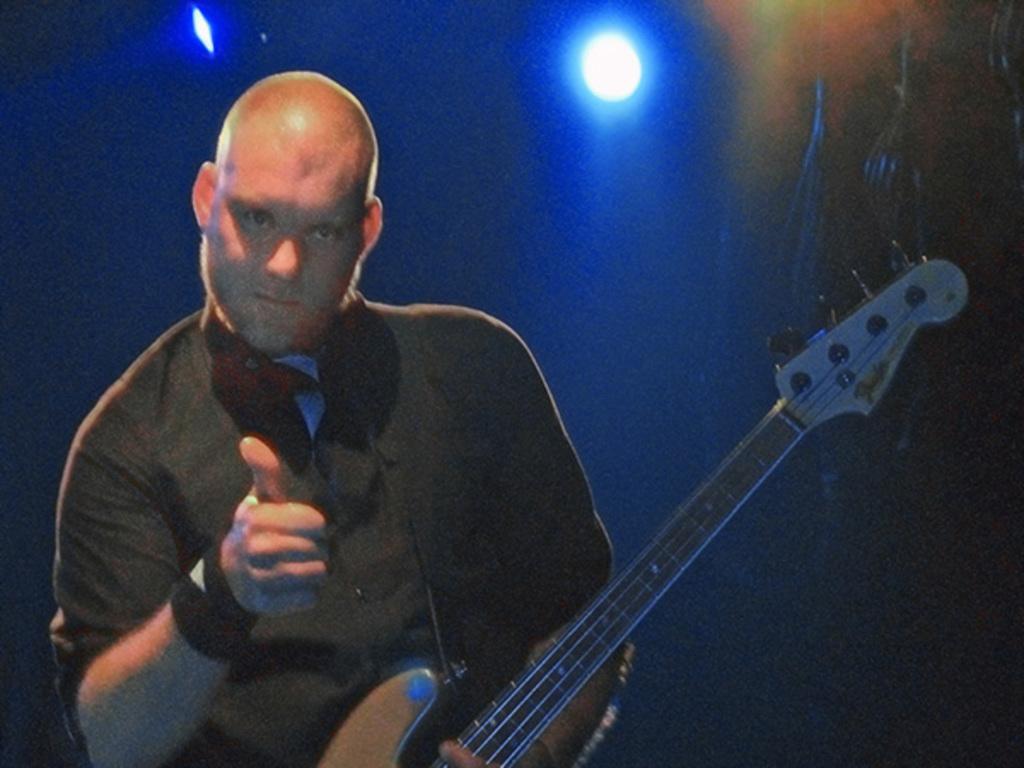Could you give a brief overview of what you see in this image? There is a man. He is indicating a sign. He is holding a guitar. He is wearing a black color shirt. In the background, there is a light. Background is in blue color. 